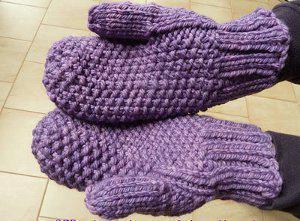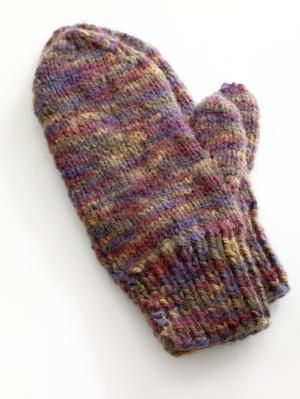The first image is the image on the left, the second image is the image on the right. Considering the images on both sides, is "And at least one image there is somebody wearing mittens where the Fingers are not visible" valid? Answer yes or no. Yes. The first image is the image on the left, the second image is the image on the right. Considering the images on both sides, is "At least one mitten is being worn and at least one mitten is not." valid? Answer yes or no. Yes. 